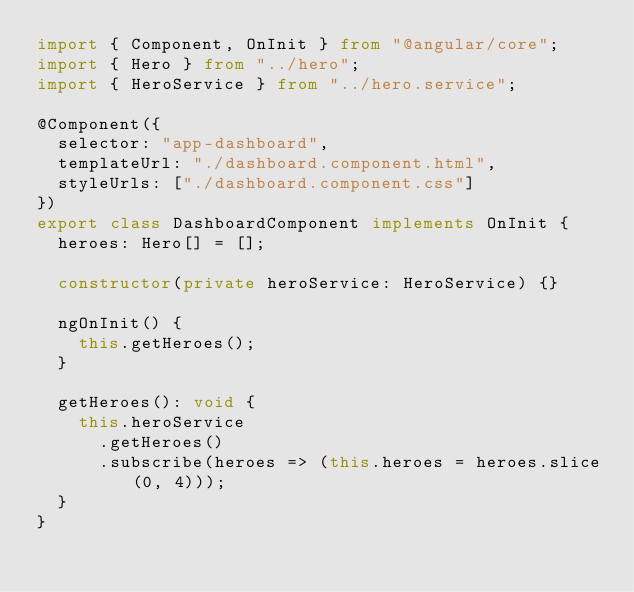Convert code to text. <code><loc_0><loc_0><loc_500><loc_500><_TypeScript_>import { Component, OnInit } from "@angular/core";
import { Hero } from "../hero";
import { HeroService } from "../hero.service";

@Component({
  selector: "app-dashboard",
  templateUrl: "./dashboard.component.html",
  styleUrls: ["./dashboard.component.css"]
})
export class DashboardComponent implements OnInit {
  heroes: Hero[] = [];

  constructor(private heroService: HeroService) {}

  ngOnInit() {
    this.getHeroes();
  }

  getHeroes(): void {
    this.heroService
      .getHeroes()
      .subscribe(heroes => (this.heroes = heroes.slice(0, 4)));
  }
}
</code> 